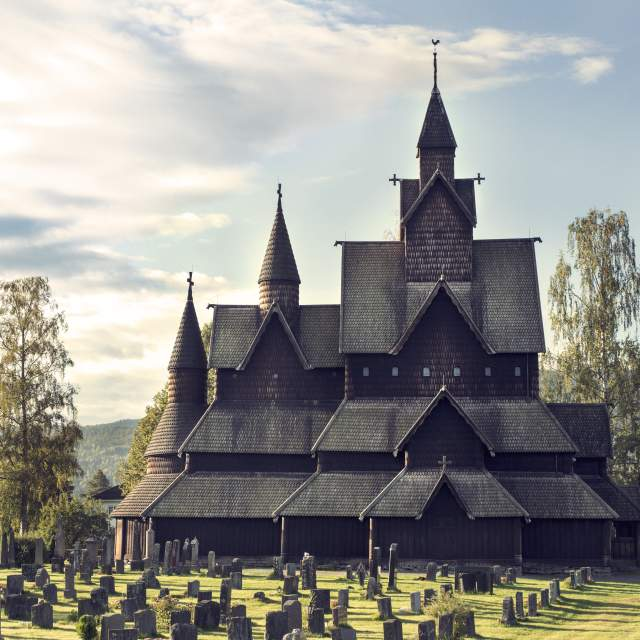Describe the following image. The image showcases the majestic Heddal Stave Church in Norway, a stunning example of traditional wooden architecture. This historical structure, made from dark, sturdy wood, features multiple intricately carved spires and steep gables, which reach upwards against the serene backdrop of a bright, clear sky. The church stands as a central monument amidst a tranquil landscape, with an ancient cemetery in the foreground. The gravestones, worn by time, add an element of reverence and history to the scene. Surrounding the church, gentle hills covered in lush green trees enhance the sense of peace and natural beauty. The overall composition provides a serene, yet awe-inspiring view, highlighting the church's architectural elegance and its harmonious integration with the natural world. 